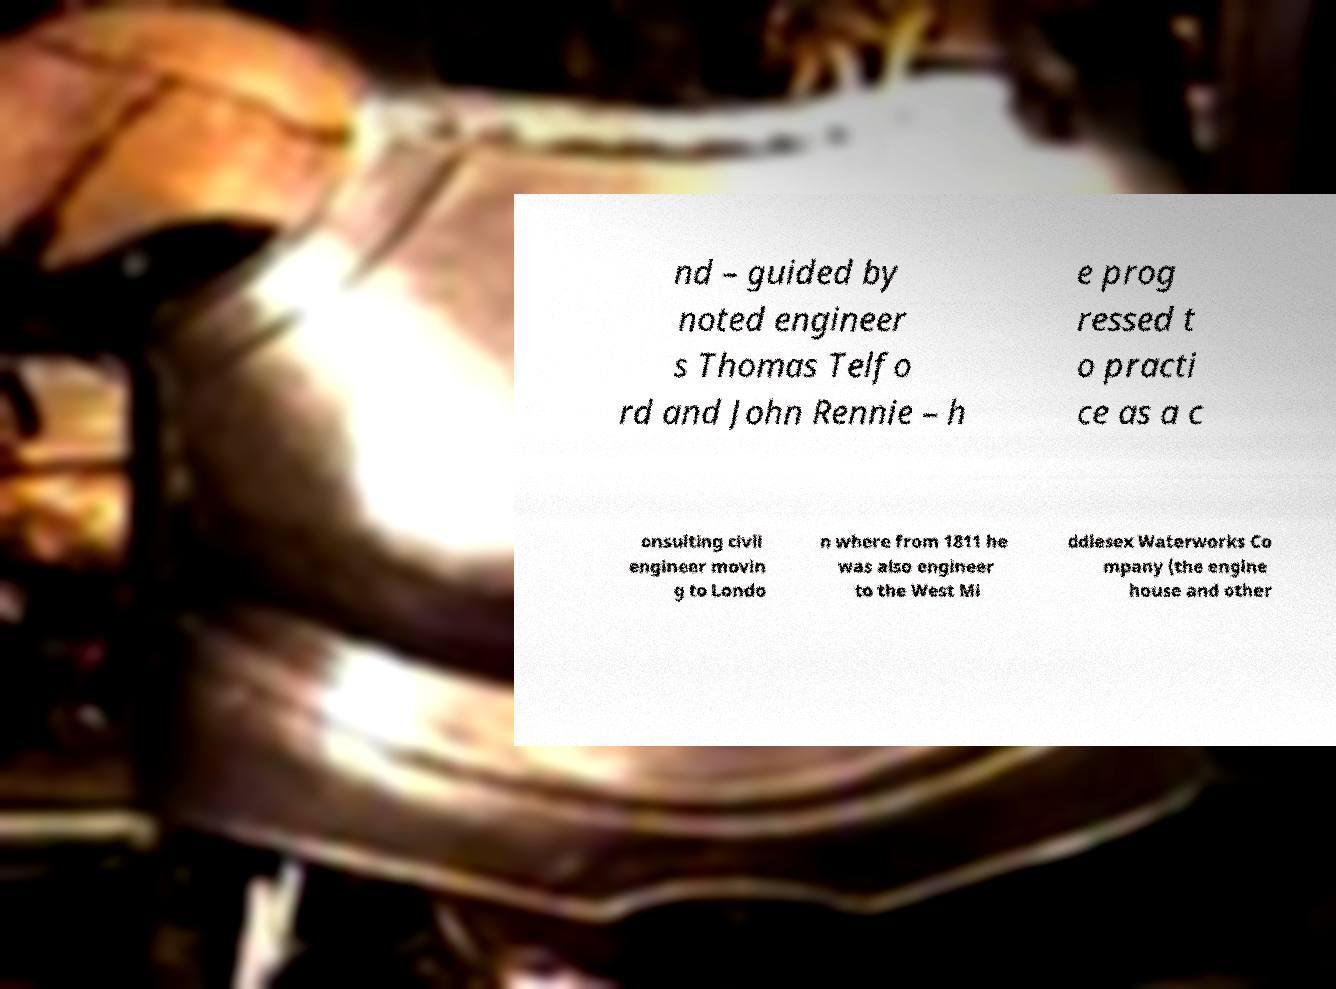There's text embedded in this image that I need extracted. Can you transcribe it verbatim? nd – guided by noted engineer s Thomas Telfo rd and John Rennie – h e prog ressed t o practi ce as a c onsulting civil engineer movin g to Londo n where from 1811 he was also engineer to the West Mi ddlesex Waterworks Co mpany (the engine house and other 